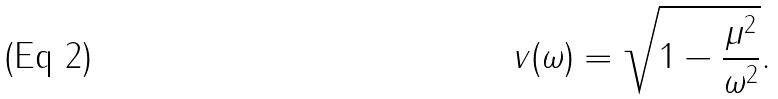Convert formula to latex. <formula><loc_0><loc_0><loc_500><loc_500>v ( \omega ) = \sqrt { 1 - \frac { \mu ^ { 2 } } { \omega ^ { 2 } } } .</formula> 